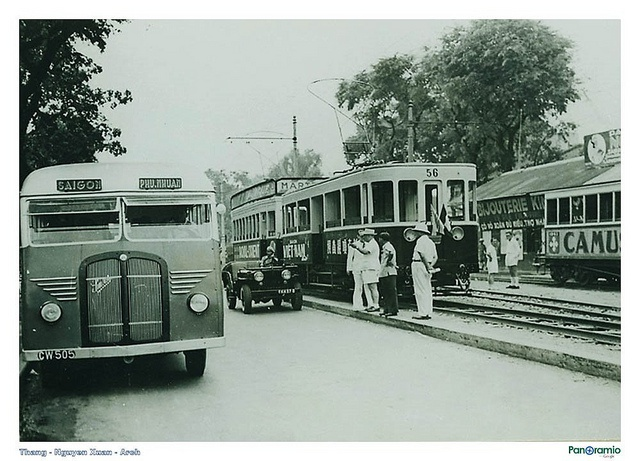Describe the objects in this image and their specific colors. I can see bus in white, black, teal, darkgray, and lightgray tones, train in white, black, darkgray, gray, and darkgreen tones, train in white, black, darkgray, gray, and ivory tones, car in white, black, gray, darkgray, and darkgreen tones, and people in white, darkgray, lightgray, and black tones in this image. 